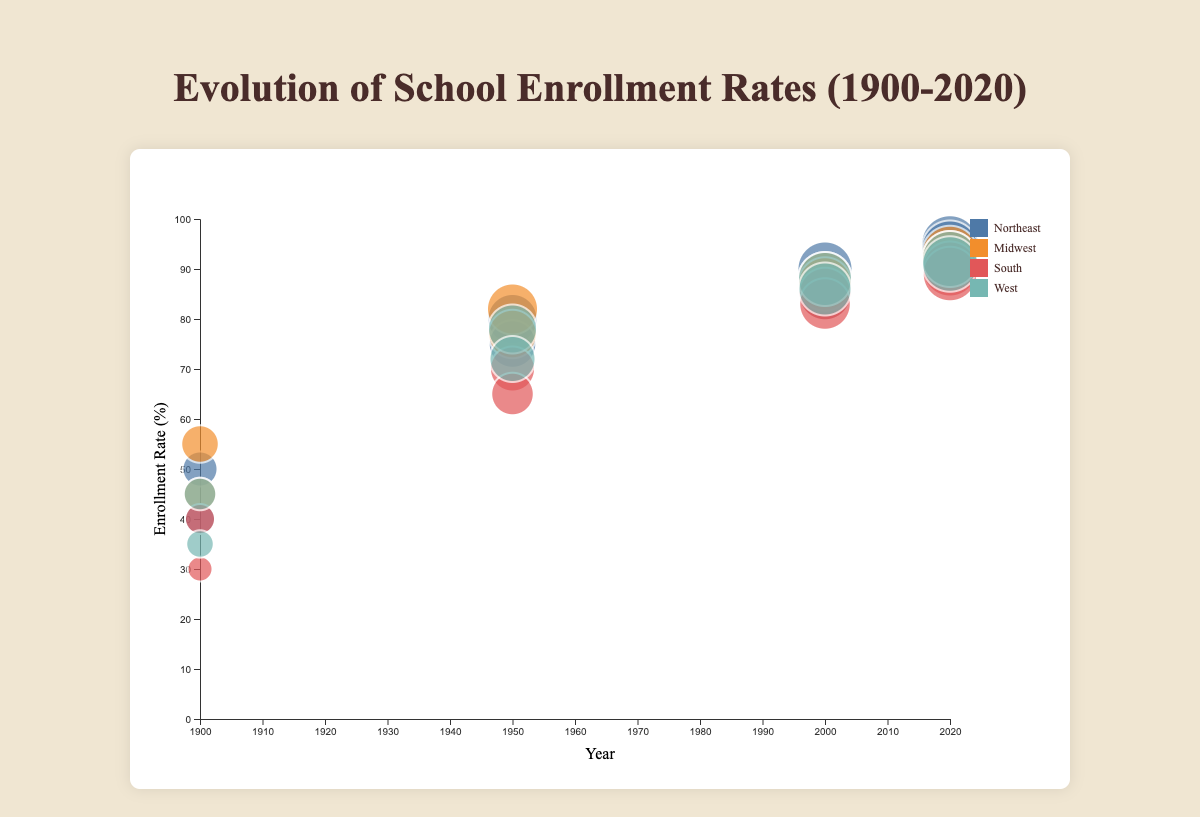What's the title of the figure? The title is usually located at the top center of a figure. Look at the top of the chart for a large, standout text.
Answer: Evolution of School Enrollment Rates (1900-2020) What does the x-axis represent? The x-axis typically labels dimensions related to time or categories. Read the label below the x-axis line to determine what it represents.
Answer: Year What do the colors of the bubbles represent? In bubble charts, colors often distinguish between different categories. Check the legend to see what categories are represented by each color.
Answer: Geographical regions How does the enrollment rate for females in the South compare from 1900 to 2020? Find the bubbles for females in the South (purple bubbles). Compare the y-coordinates for the bubbles at the years 1900 and 2020.
Answer: Increased from 30% to 89% Which gender had a higher enrollment rate in the Midwest in 2020? Look for the bubbles corresponding to the Midwest in 2020. Compare the y-coordinates of the male and female bubbles.
Answer: Male What is the difference in enrollment rate for males between the Northeast and the South in 1950? Identify the bubbles for males in 1950 for both regions. Subtract the enrollment rate for the South from that of the Northeast.
Answer: 10% Which region had the lowest female enrollment rate in 2000? Find the bubbles for females in 2000 for all regions. The bubble with the lowest y-coordinate corresponds to the lowest enrollment rate.
Answer: South What is the average enrollment rate for males in the Midwest from 1950 to 2020? Locate the enrollment rates for males in the Midwest for the years 1950, 2000, and 2020. Calculate the average of these values: (82 + 88 + 93) / 3.
Answer: 87.67% How have school enrollment rates for males and females in the West converged from 1900 to 2020? Look at the bubbles for males and females in the West for the years 1900 and 2020. Compare their vertical distances in 1900 and 2020 to assess convergence.
Answer: They have converged from a 10% difference in 1900 to a 1% difference in 2020 